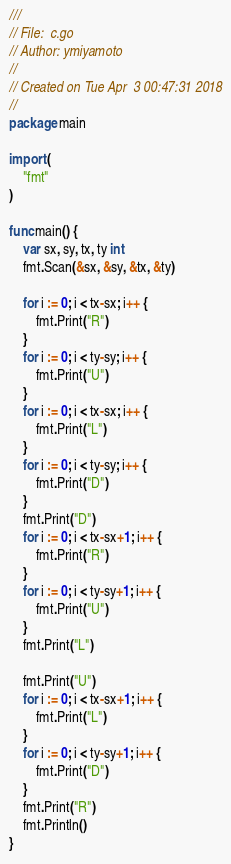Convert code to text. <code><loc_0><loc_0><loc_500><loc_500><_Go_>///
// File:  c.go
// Author: ymiyamoto
//
// Created on Tue Apr  3 00:47:31 2018
//
package main

import (
	"fmt"
)

func main() {
	var sx, sy, tx, ty int
	fmt.Scan(&sx, &sy, &tx, &ty)

	for i := 0; i < tx-sx; i++ {
		fmt.Print("R")
	}
	for i := 0; i < ty-sy; i++ {
		fmt.Print("U")
	}
	for i := 0; i < tx-sx; i++ {
		fmt.Print("L")
	}
	for i := 0; i < ty-sy; i++ {
		fmt.Print("D")
	}
	fmt.Print("D")
	for i := 0; i < tx-sx+1; i++ {
		fmt.Print("R")
	}
	for i := 0; i < ty-sy+1; i++ {
		fmt.Print("U")
	}
	fmt.Print("L")

	fmt.Print("U")
	for i := 0; i < tx-sx+1; i++ {
		fmt.Print("L")
	}
	for i := 0; i < ty-sy+1; i++ {
		fmt.Print("D")
	}
	fmt.Print("R")
	fmt.Println()
}
</code> 